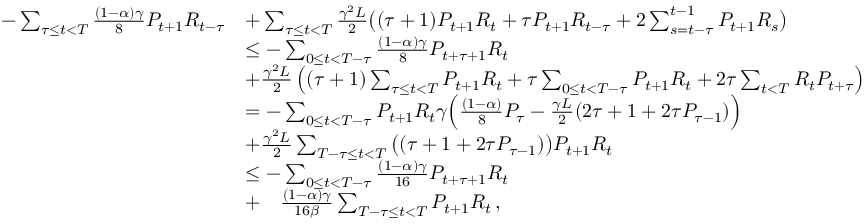Convert formula to latex. <formula><loc_0><loc_0><loc_500><loc_500>\begin{array} { r l } { - \sum _ { \tau \leq t < T } \frac { ( 1 - \alpha ) \gamma } { 8 } P _ { t + 1 } R _ { t - \tau } } & { + \sum _ { \tau \leq t < T } \frac { \gamma ^ { 2 } L } { 2 } \left ( ( \tau + 1 ) P _ { t + 1 } R _ { t } + \tau P _ { t + 1 } R _ { t - \tau } + 2 \sum _ { s = t - \tau } ^ { t - 1 } P _ { t + 1 } R _ { s } \right ) } \\ & { \leq - \sum _ { 0 \leq t < T - \tau } \frac { ( 1 - \alpha ) \gamma } { 8 } P _ { t + \tau + 1 } R _ { t } } \\ & { + \frac { \gamma ^ { 2 } L } { 2 } \left ( ( \tau + 1 ) \sum _ { \tau \leq t < T } P _ { t + 1 } R _ { t } + \tau \sum _ { 0 \leq t < T - \tau } P _ { t + 1 } R _ { t } + 2 \tau \sum _ { t < T } R _ { t } P _ { t + \tau } \right ) } \\ & { = - \sum _ { 0 \leq t < T - \tau } P _ { t + 1 } R _ { t } \gamma \left ( \frac { ( 1 - \alpha ) } { 8 } P _ { \tau } - \frac { \gamma L } { 2 } ( 2 \tau + 1 + 2 \tau P _ { \tau - 1 } ) \right ) } \\ & { + \frac { \gamma ^ { 2 } L } { 2 } \sum _ { T - \tau \leq t < T } \left ( ( \tau + 1 + 2 \tau P _ { \tau - 1 } ) \right ) P _ { t + 1 } R _ { t } } \\ & { \leq - \sum _ { 0 \leq t < T - \tau } \frac { ( 1 - \alpha ) \gamma } { 1 6 } P _ { t + \tau + 1 } R _ { t } } \\ & { + \quad \frac { ( 1 - \alpha ) \gamma } { 1 6 \beta } \sum _ { T - \tau \leq t < T } P _ { t + 1 } R _ { t } \, , } \end{array}</formula> 